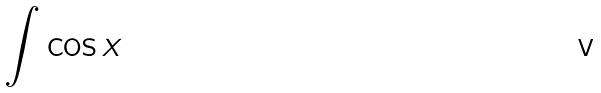<formula> <loc_0><loc_0><loc_500><loc_500>\int \cos x</formula> 